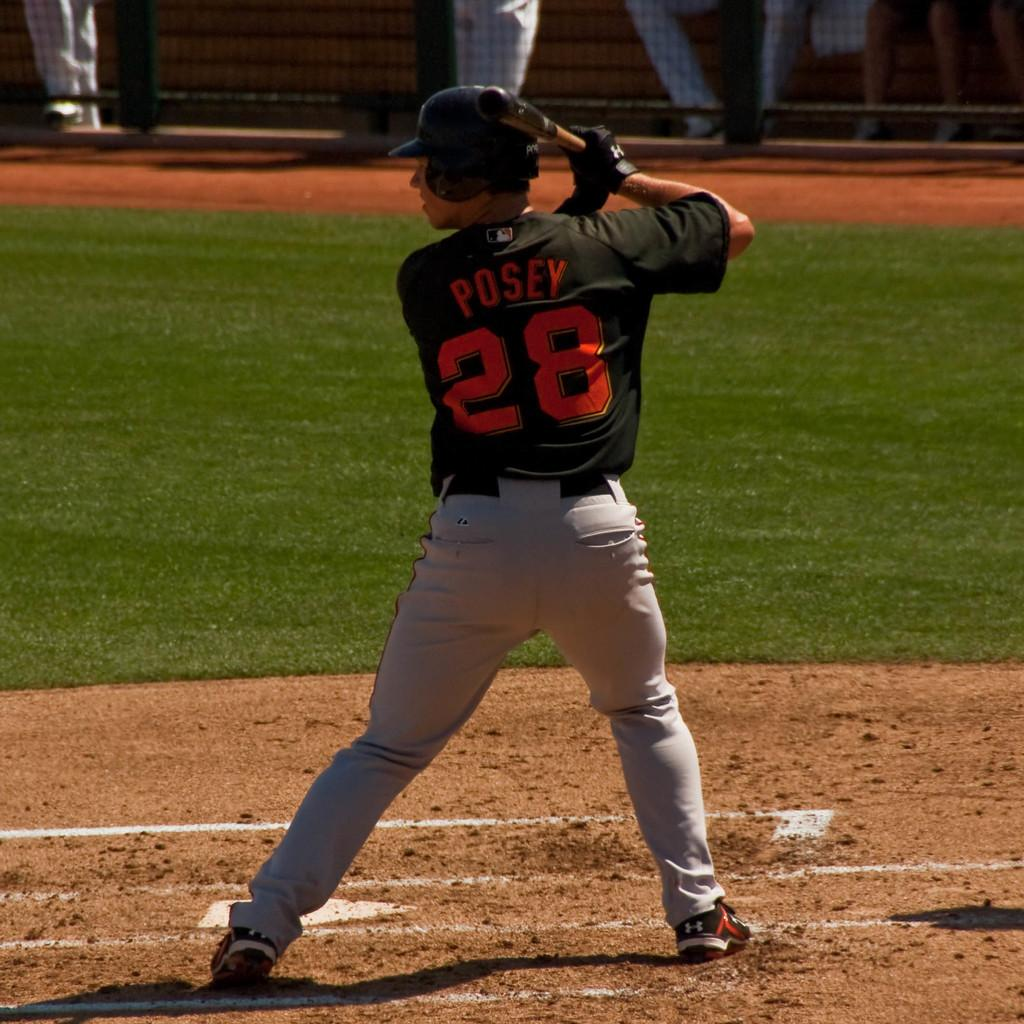Provide a one-sentence caption for the provided image. A baseball player has the number 28 on his shirt. 